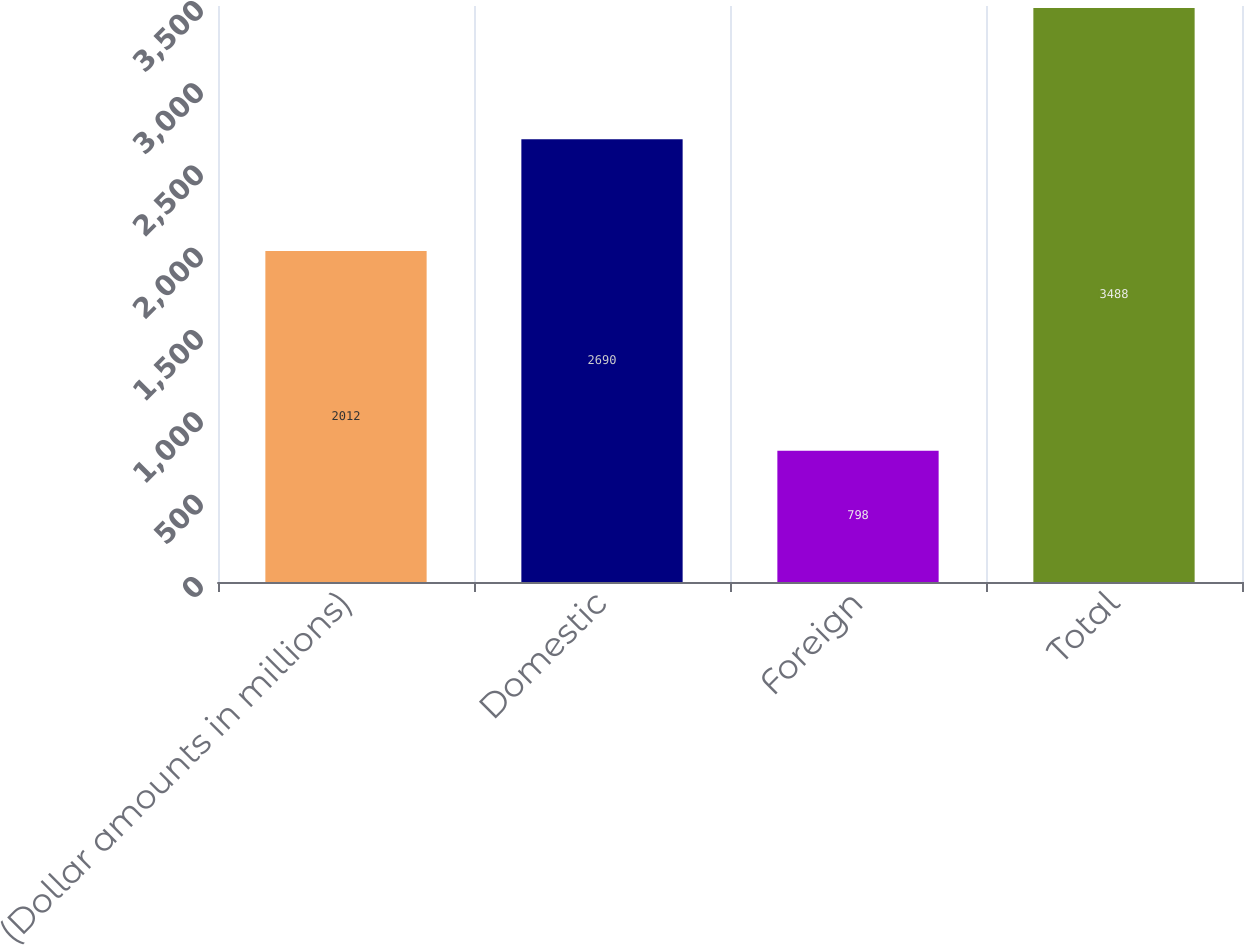Convert chart to OTSL. <chart><loc_0><loc_0><loc_500><loc_500><bar_chart><fcel>(Dollar amounts in millions)<fcel>Domestic<fcel>Foreign<fcel>Total<nl><fcel>2012<fcel>2690<fcel>798<fcel>3488<nl></chart> 